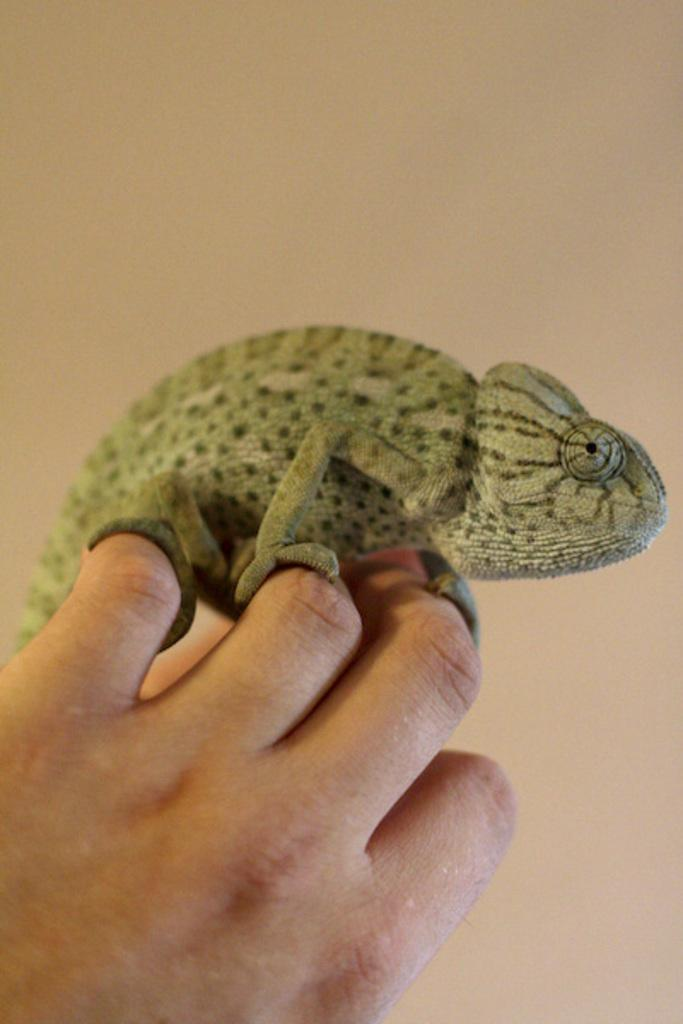What can be seen in the foreground of the image? There is a person's hand in the foreground of the image. What is the hand holding? The hand is holding a chameleon. What is visible in the background of the image? There is an object in the background that appears to be a wall. What type of lead is being used to guide the chameleon in the image? There is no lead present in the image, and the chameleon is being held by a person's hand. 